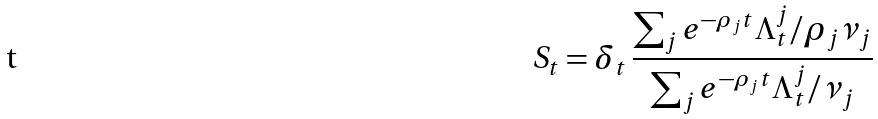<formula> <loc_0><loc_0><loc_500><loc_500>S _ { t } = \delta _ { t } \, \frac { \sum _ { j } e ^ { - \rho _ { j } t } \Lambda _ { t } ^ { j } / \rho _ { j } \nu _ { j } } { \sum _ { j } e ^ { - \rho _ { j } t } \Lambda _ { t } ^ { j } / \nu _ { j } }</formula> 